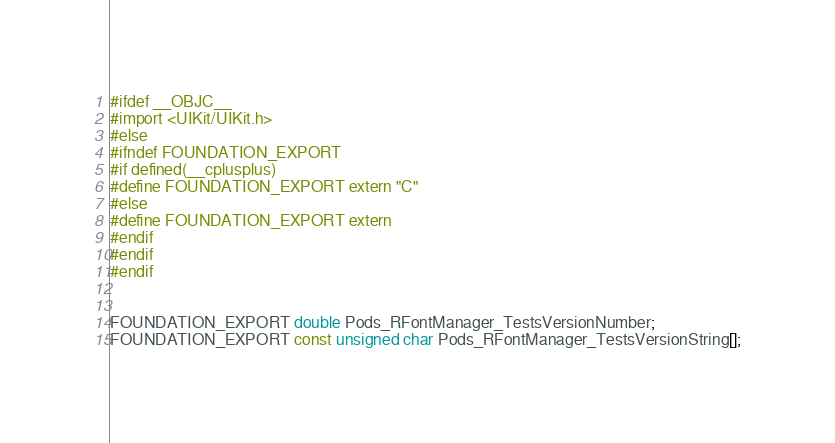<code> <loc_0><loc_0><loc_500><loc_500><_C_>#ifdef __OBJC__
#import <UIKit/UIKit.h>
#else
#ifndef FOUNDATION_EXPORT
#if defined(__cplusplus)
#define FOUNDATION_EXPORT extern "C"
#else
#define FOUNDATION_EXPORT extern
#endif
#endif
#endif


FOUNDATION_EXPORT double Pods_RFontManager_TestsVersionNumber;
FOUNDATION_EXPORT const unsigned char Pods_RFontManager_TestsVersionString[];

</code> 